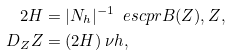Convert formula to latex. <formula><loc_0><loc_0><loc_500><loc_500>2 H & = | N _ { h } | ^ { - 1 } \, \ e s c p r { B ( Z ) , Z } , \\ D _ { Z } Z & = ( 2 H ) \, \nu h ,</formula> 